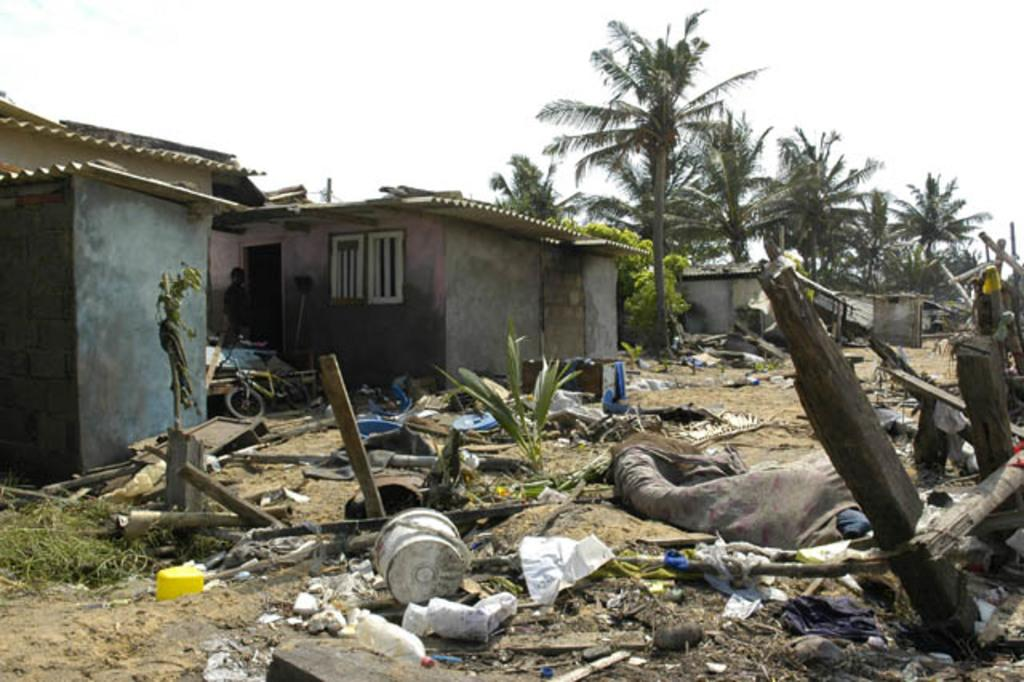What type of natural elements can be seen in the image? There are trees and plants in the image. What type of structures are present in the image? There are sheds in the image. What type of materials are visible on the ground in the image? There are logs in the image. What type of personal items can be seen in the image? There are clothes in the image. What type of transportation is present in the image? There is a bicycle in the image. Who or what is present in the image? There is a person in the image. What other objects can be seen on the ground in the image? There are other objects on the ground in the image. What is visible at the top of the image? The sky is visible at the top of the image. Can you see any goldfish swimming in the image? There are no goldfish present in the image. What type of silk fabric is draped over the person in the image? There is no silk fabric present in the image. 